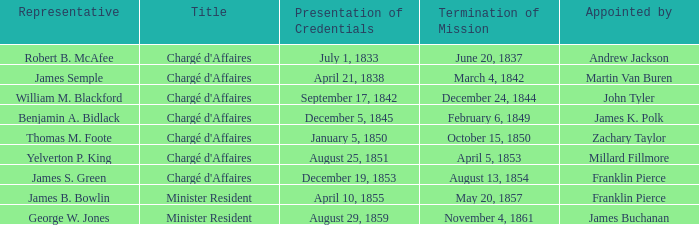Which Title has an Appointed by of Millard Fillmore? Chargé d'Affaires. 